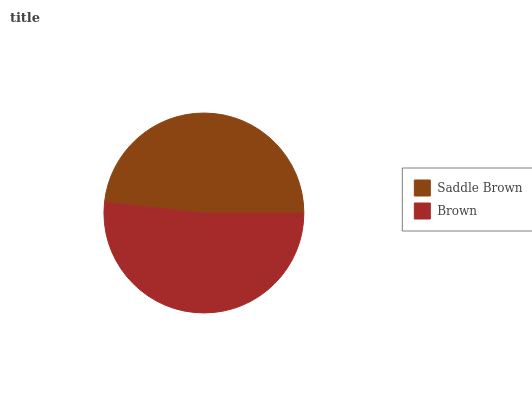Is Saddle Brown the minimum?
Answer yes or no. Yes. Is Brown the maximum?
Answer yes or no. Yes. Is Brown the minimum?
Answer yes or no. No. Is Brown greater than Saddle Brown?
Answer yes or no. Yes. Is Saddle Brown less than Brown?
Answer yes or no. Yes. Is Saddle Brown greater than Brown?
Answer yes or no. No. Is Brown less than Saddle Brown?
Answer yes or no. No. Is Brown the high median?
Answer yes or no. Yes. Is Saddle Brown the low median?
Answer yes or no. Yes. Is Saddle Brown the high median?
Answer yes or no. No. Is Brown the low median?
Answer yes or no. No. 